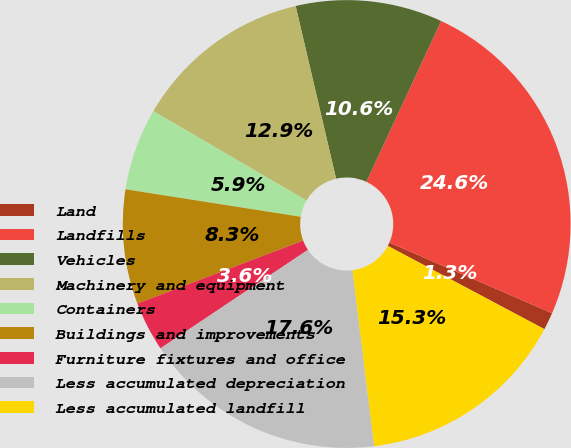Convert chart to OTSL. <chart><loc_0><loc_0><loc_500><loc_500><pie_chart><fcel>Land<fcel>Landfills<fcel>Vehicles<fcel>Machinery and equipment<fcel>Containers<fcel>Buildings and improvements<fcel>Furniture fixtures and office<fcel>Less accumulated depreciation<fcel>Less accumulated landfill<nl><fcel>1.26%<fcel>24.59%<fcel>10.59%<fcel>12.93%<fcel>5.93%<fcel>8.26%<fcel>3.59%<fcel>17.59%<fcel>15.26%<nl></chart> 